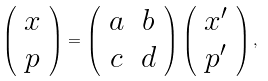<formula> <loc_0><loc_0><loc_500><loc_500>\left ( \begin{array} { c } x \\ p \end{array} \right ) = \left ( \begin{array} { c c } a & b \\ c & d \end{array} \right ) \left ( \begin{array} { c } x ^ { \prime } \\ p ^ { \prime } \end{array} \right ) ,</formula> 